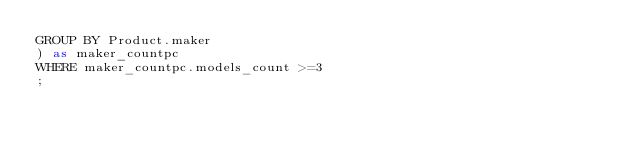Convert code to text. <code><loc_0><loc_0><loc_500><loc_500><_SQL_>GROUP BY Product.maker
) as maker_countpc
WHERE maker_countpc.models_count >=3
;</code> 